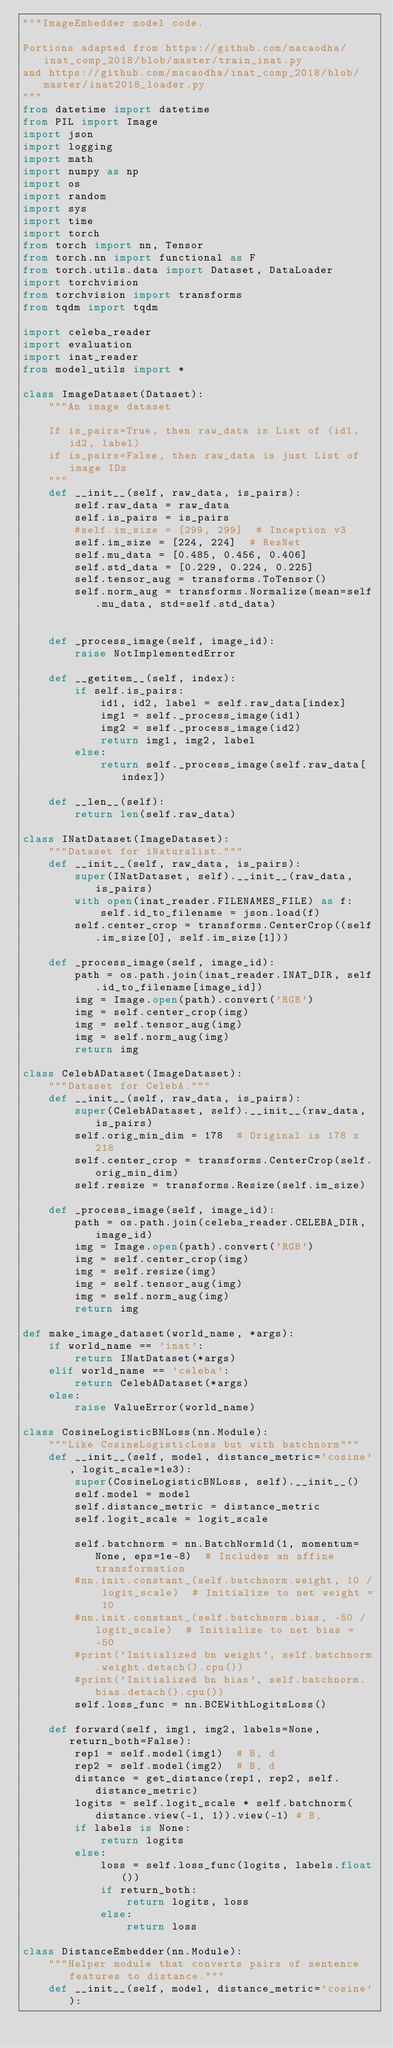Convert code to text. <code><loc_0><loc_0><loc_500><loc_500><_Python_>"""ImageEmbedder model code.

Portions adapted from https://github.com/macaodha/inat_comp_2018/blob/master/train_inat.py
and https://github.com/macaodha/inat_comp_2018/blob/master/inat2018_loader.py
"""
from datetime import datetime
from PIL import Image
import json
import logging
import math
import numpy as np
import os
import random
import sys
import time
import torch
from torch import nn, Tensor
from torch.nn import functional as F
from torch.utils.data import Dataset, DataLoader
import torchvision
from torchvision import transforms
from tqdm import tqdm

import celeba_reader
import evaluation
import inat_reader
from model_utils import *

class ImageDataset(Dataset):
    """An image dataset

    If is_pairs=True, then raw_data is List of (id1, id2, label)
    if is_pairs=False, then raw_data is just List of image IDs
    """
    def __init__(self, raw_data, is_pairs):
        self.raw_data = raw_data
        self.is_pairs = is_pairs
        #self.im_size = [299, 299]  # Inception v3
        self.im_size = [224, 224]  # ResNet
        self.mu_data = [0.485, 0.456, 0.406]
        self.std_data = [0.229, 0.224, 0.225]
        self.tensor_aug = transforms.ToTensor()
        self.norm_aug = transforms.Normalize(mean=self.mu_data, std=self.std_data)


    def _process_image(self, image_id):
        raise NotImplementedError

    def __getitem__(self, index):
        if self.is_pairs:
            id1, id2, label = self.raw_data[index]
            img1 = self._process_image(id1)
            img2 = self._process_image(id2)
            return img1, img2, label
        else:
            return self._process_image(self.raw_data[index])

    def __len__(self):
        return len(self.raw_data)

class INatDataset(ImageDataset):
    """Dataset for iNaturalist."""
    def __init__(self, raw_data, is_pairs):
        super(INatDataset, self).__init__(raw_data, is_pairs)
        with open(inat_reader.FILENAMES_FILE) as f:
            self.id_to_filename = json.load(f)
        self.center_crop = transforms.CenterCrop((self.im_size[0], self.im_size[1]))

    def _process_image(self, image_id):
        path = os.path.join(inat_reader.INAT_DIR, self.id_to_filename[image_id])
        img = Image.open(path).convert('RGB')
        img = self.center_crop(img)
        img = self.tensor_aug(img)
        img = self.norm_aug(img)
        return img

class CelebADataset(ImageDataset):
    """Dataset for CelebA."""
    def __init__(self, raw_data, is_pairs):
        super(CelebADataset, self).__init__(raw_data, is_pairs)
        self.orig_min_dim = 178  # Original is 178 x 218
        self.center_crop = transforms.CenterCrop(self.orig_min_dim)
        self.resize = transforms.Resize(self.im_size)

    def _process_image(self, image_id):
        path = os.path.join(celeba_reader.CELEBA_DIR, image_id)
        img = Image.open(path).convert('RGB')
        img = self.center_crop(img)
        img = self.resize(img)
        img = self.tensor_aug(img)
        img = self.norm_aug(img)
        return img

def make_image_dataset(world_name, *args):
    if world_name == 'inat':
        return INatDataset(*args)
    elif world_name == 'celeba':
        return CelebADataset(*args)
    else:
        raise ValueError(world_name) 

class CosineLogisticBNLoss(nn.Module):
    """Like CosineLogisticLoss but with batchnorm"""
    def __init__(self, model, distance_metric='cosine', logit_scale=1e3):
        super(CosineLogisticBNLoss, self).__init__()
        self.model = model
        self.distance_metric = distance_metric
        self.logit_scale = logit_scale

        self.batchnorm = nn.BatchNorm1d(1, momentum=None, eps=1e-8)  # Includes an affine transformation
        #nn.init.constant_(self.batchnorm.weight, 10 / logit_scale)  # Initialize to net weight = 10
        #nn.init.constant_(self.batchnorm.bias, -50 / logit_scale)  # Initialize to net bias = -50
        #print('Initialized bn weight', self.batchnorm.weight.detach().cpu())
        #print('Initialized bn bias', self.batchnorm.bias.detach().cpu())
        self.loss_func = nn.BCEWithLogitsLoss()

    def forward(self, img1, img2, labels=None, return_both=False):
        rep1 = self.model(img1)  # B, d
        rep2 = self.model(img2)  # B, d
        distance = get_distance(rep1, rep2, self.distance_metric)
        logits = self.logit_scale * self.batchnorm(distance.view(-1, 1)).view(-1) # B,
        if labels is None:
            return logits
        else:
            loss = self.loss_func(logits, labels.float())
            if return_both:
                return logits, loss
            else:
                return loss

class DistanceEmbedder(nn.Module):
    """Helper module that converts pairs of sentence features to distance.""" 
    def __init__(self, model, distance_metric='cosine'):</code> 